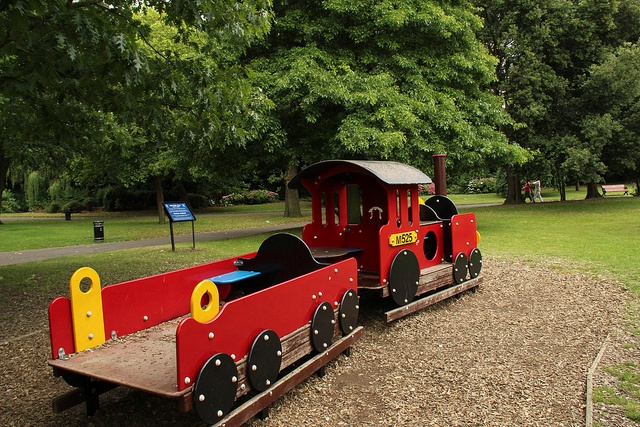Describe the objects in this image and their specific colors. I can see train in black, brown, and maroon tones, bench in black, tan, and olive tones, people in black, gray, and darkgray tones, and people in black, maroon, and brown tones in this image. 